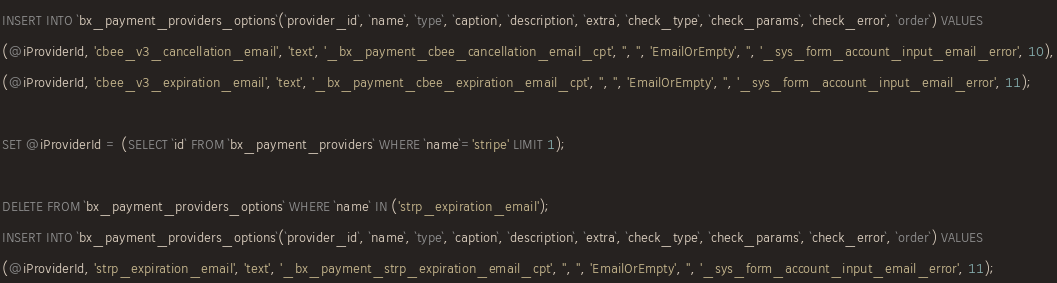Convert code to text. <code><loc_0><loc_0><loc_500><loc_500><_SQL_>INSERT INTO `bx_payment_providers_options`(`provider_id`, `name`, `type`, `caption`, `description`, `extra`, `check_type`, `check_params`, `check_error`, `order`) VALUES
(@iProviderId, 'cbee_v3_cancellation_email', 'text', '_bx_payment_cbee_cancellation_email_cpt', '', '', 'EmailOrEmpty', '', '_sys_form_account_input_email_error', 10),
(@iProviderId, 'cbee_v3_expiration_email', 'text', '_bx_payment_cbee_expiration_email_cpt', '', '', 'EmailOrEmpty', '', '_sys_form_account_input_email_error', 11);

SET @iProviderId = (SELECT `id` FROM `bx_payment_providers` WHERE `name`='stripe' LIMIT 1);

DELETE FROM `bx_payment_providers_options` WHERE `name` IN ('strp_expiration_email');
INSERT INTO `bx_payment_providers_options`(`provider_id`, `name`, `type`, `caption`, `description`, `extra`, `check_type`, `check_params`, `check_error`, `order`) VALUES
(@iProviderId, 'strp_expiration_email', 'text', '_bx_payment_strp_expiration_email_cpt', '', '', 'EmailOrEmpty', '', '_sys_form_account_input_email_error', 11);
</code> 